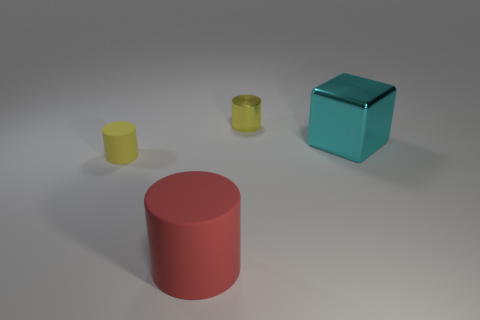How many metallic things are there?
Ensure brevity in your answer.  2. There is a thing that is both behind the tiny yellow matte cylinder and left of the cyan thing; what is its shape?
Give a very brief answer. Cylinder. Do the cylinder that is behind the yellow matte thing and the matte object on the left side of the large red matte cylinder have the same color?
Your answer should be very brief. Yes. There is a matte thing that is the same color as the small shiny cylinder; what size is it?
Your answer should be compact. Small. Are there any tiny things made of the same material as the big cylinder?
Keep it short and to the point. Yes. Is the number of yellow metallic objects that are in front of the big red cylinder the same as the number of yellow matte objects behind the big cyan block?
Offer a very short reply. Yes. There is a yellow cylinder that is on the right side of the yellow matte thing; what is its size?
Your answer should be compact. Small. The tiny object that is behind the matte cylinder that is behind the large red matte cylinder is made of what material?
Provide a short and direct response. Metal. There is a tiny yellow rubber thing behind the big object that is on the left side of the small yellow shiny cylinder; how many rubber things are on the left side of it?
Ensure brevity in your answer.  0. Do the cyan block on the right side of the large red thing and the tiny object left of the large red rubber cylinder have the same material?
Your answer should be compact. No. 